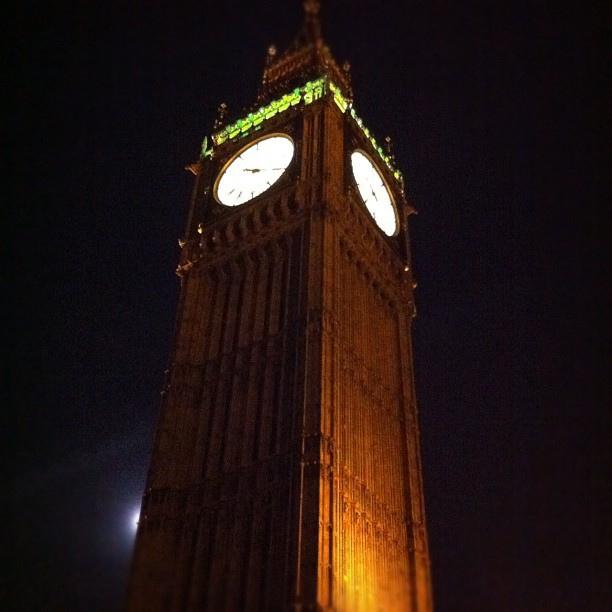Is this a clock tower?
Answer briefly. Yes. Is the clock lit up?
Short answer required. Yes. Is it after midnight?
Be succinct. No. How many spires are visible?
Answer briefly. 1. 